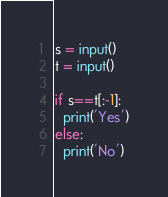<code> <loc_0><loc_0><loc_500><loc_500><_Python_>s = input()
t = input()

if s==t[:-1]:
  print('Yes')
else:
  print('No')</code> 